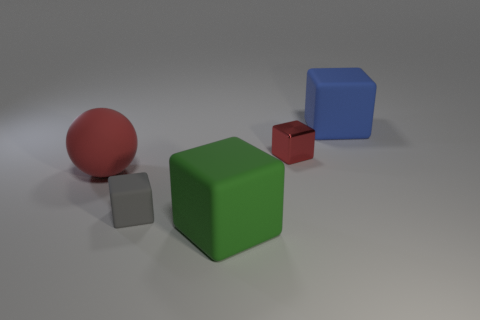Is the color of the big rubber thing that is on the left side of the gray rubber object the same as the small object right of the green rubber cube?
Make the answer very short. Yes. Does the object that is to the left of the small gray object have the same size as the gray cube in front of the red metal block?
Offer a very short reply. No. There is a thing that is the same color as the sphere; what is it made of?
Your answer should be very brief. Metal. How many other objects are the same color as the small metallic object?
Your response must be concise. 1. How many tiny cubes are to the left of the green matte cube?
Your response must be concise. 1. There is a tiny cube that is on the right side of the tiny block in front of the red rubber sphere; what is its material?
Provide a succinct answer. Metal. Do the ball and the green rubber object have the same size?
Your answer should be very brief. Yes. What number of things are either tiny things left of the small red cube or matte things left of the green matte object?
Ensure brevity in your answer.  2. Is the number of objects that are behind the metal thing greater than the number of big brown balls?
Your answer should be compact. Yes. What number of other things are the same shape as the small red metal thing?
Offer a terse response. 3. 